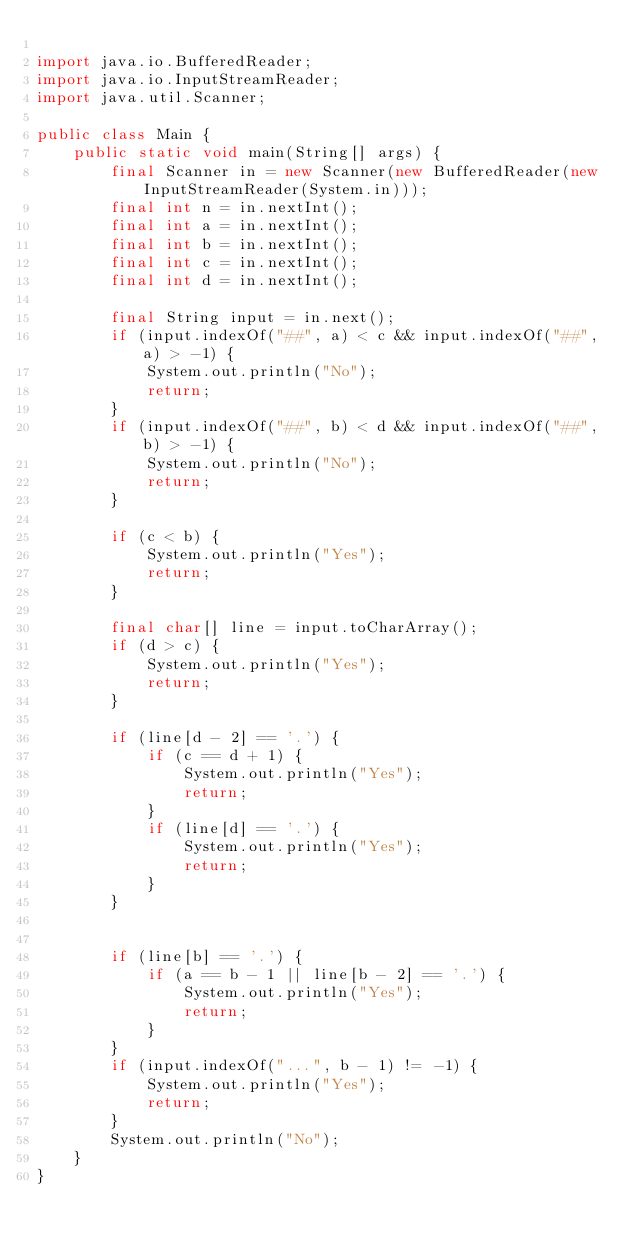Convert code to text. <code><loc_0><loc_0><loc_500><loc_500><_Java_>
import java.io.BufferedReader;
import java.io.InputStreamReader;
import java.util.Scanner;

public class Main {
    public static void main(String[] args) {
        final Scanner in = new Scanner(new BufferedReader(new InputStreamReader(System.in)));
        final int n = in.nextInt();
        final int a = in.nextInt();
        final int b = in.nextInt();
        final int c = in.nextInt();
        final int d = in.nextInt();

        final String input = in.next();
        if (input.indexOf("##", a) < c && input.indexOf("##", a) > -1) {
            System.out.println("No");
            return;
        }
        if (input.indexOf("##", b) < d && input.indexOf("##", b) > -1) {
            System.out.println("No");
            return;
        }

        if (c < b) {
            System.out.println("Yes");
            return;
        }

        final char[] line = input.toCharArray();
        if (d > c) {
            System.out.println("Yes");
            return;
        }

        if (line[d - 2] == '.') {
            if (c == d + 1) {
                System.out.println("Yes");
                return;
            }
            if (line[d] == '.') {
                System.out.println("Yes");
                return;
            }
        }


        if (line[b] == '.') {
            if (a == b - 1 || line[b - 2] == '.') {
                System.out.println("Yes");
                return;
            }
        }
        if (input.indexOf("...", b - 1) != -1) {
            System.out.println("Yes");
            return;
        }
        System.out.println("No");
    }
}
</code> 